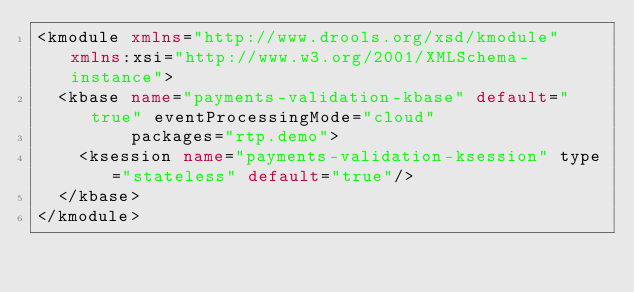<code> <loc_0><loc_0><loc_500><loc_500><_XML_><kmodule xmlns="http://www.drools.org/xsd/kmodule" xmlns:xsi="http://www.w3.org/2001/XMLSchema-instance">
  <kbase name="payments-validation-kbase" default="true" eventProcessingMode="cloud"
         packages="rtp.demo">
    <ksession name="payments-validation-ksession" type="stateless" default="true"/>
  </kbase>
</kmodule>
</code> 